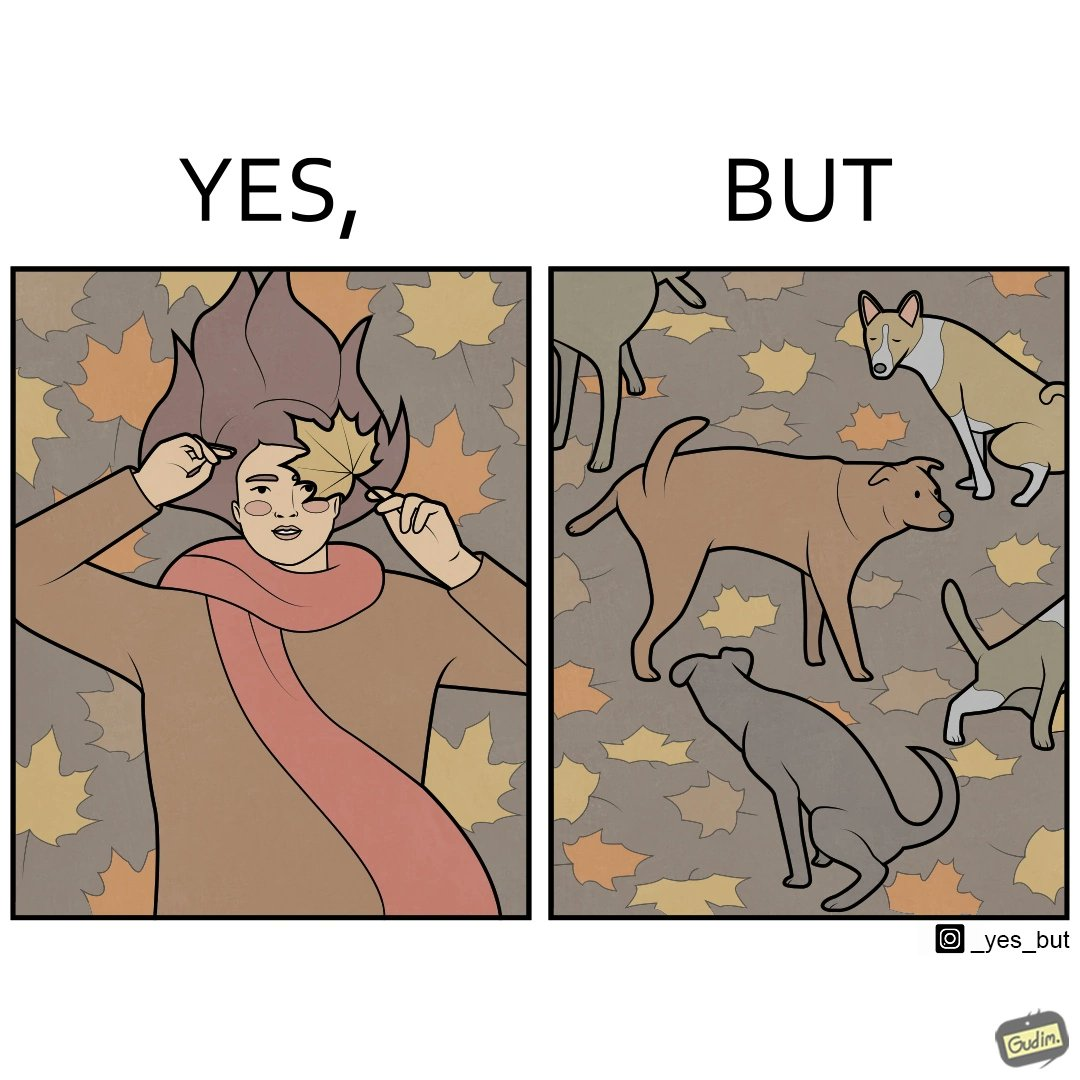Is there satirical content in this image? Yes, this image is satirical. 